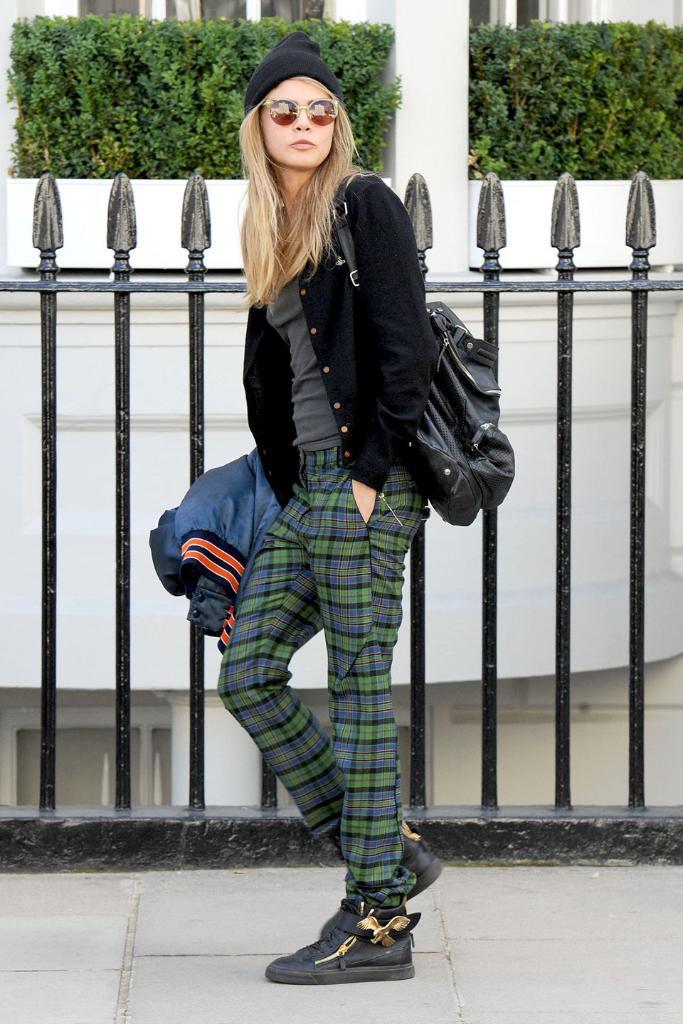Could you give a brief overview of what you see in this image? In this image we can see a woman standing beside the fence. On the backside we can see a building with windows and pillar. We can also see some plants. 